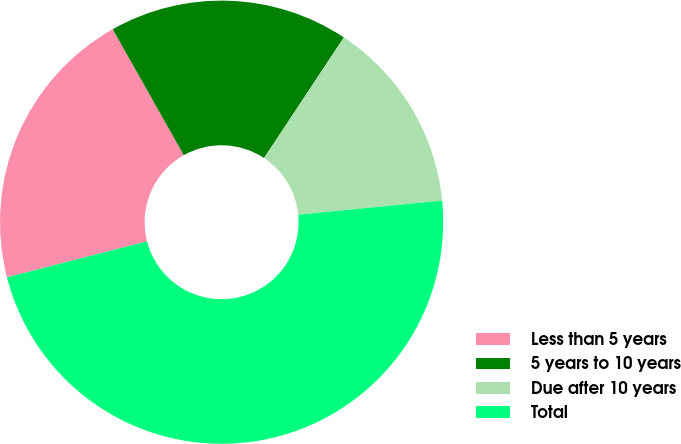Convert chart. <chart><loc_0><loc_0><loc_500><loc_500><pie_chart><fcel>Less than 5 years<fcel>5 years to 10 years<fcel>Due after 10 years<fcel>Total<nl><fcel>20.82%<fcel>17.48%<fcel>14.14%<fcel>47.56%<nl></chart> 